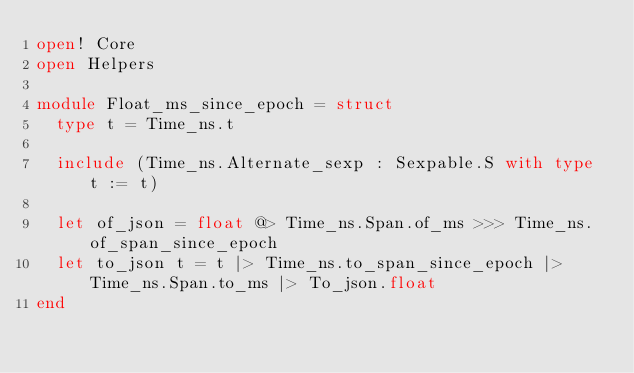Convert code to text. <code><loc_0><loc_0><loc_500><loc_500><_OCaml_>open! Core
open Helpers

module Float_ms_since_epoch = struct
  type t = Time_ns.t

  include (Time_ns.Alternate_sexp : Sexpable.S with type t := t)

  let of_json = float @> Time_ns.Span.of_ms >>> Time_ns.of_span_since_epoch
  let to_json t = t |> Time_ns.to_span_since_epoch |> Time_ns.Span.to_ms |> To_json.float
end
</code> 